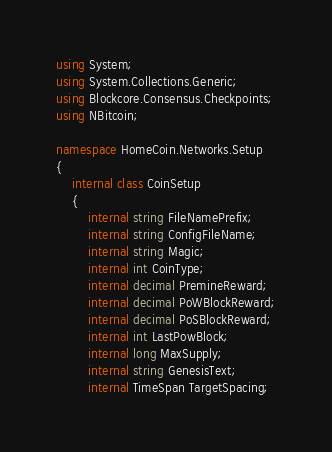<code> <loc_0><loc_0><loc_500><loc_500><_C#_>using System;
using System.Collections.Generic;
using Blockcore.Consensus.Checkpoints;
using NBitcoin;

namespace HomeCoin.Networks.Setup
{
    internal class CoinSetup
    {
        internal string FileNamePrefix;
        internal string ConfigFileName;
        internal string Magic;
        internal int CoinType;
        internal decimal PremineReward;
        internal decimal PoWBlockReward;
        internal decimal PoSBlockReward;
        internal int LastPowBlock;
        internal long MaxSupply;
        internal string GenesisText;
        internal TimeSpan TargetSpacing;</code> 